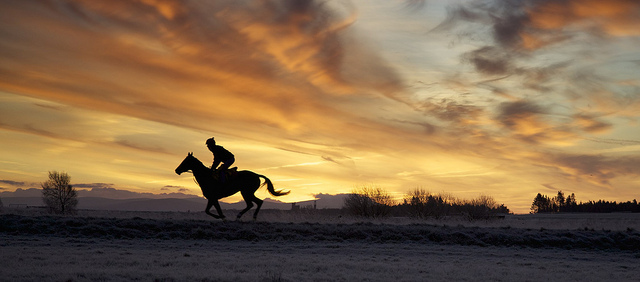How many real live dogs are in the photo? There are no real live dogs visible in the photo, which captures a beautiful scene of a lone horse and rider silhouetted against a vibrant sunset sky. 